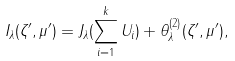Convert formula to latex. <formula><loc_0><loc_0><loc_500><loc_500>I _ { \lambda } ( \zeta ^ { \prime } , \mu ^ { \prime } ) = J _ { \lambda } ( \sum _ { i = 1 } ^ { k } U _ { i } ) + \theta _ { \lambda } ^ { ( 2 ) } ( \zeta ^ { \prime } , \mu ^ { \prime } ) ,</formula> 